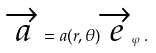<formula> <loc_0><loc_0><loc_500><loc_500>\overrightarrow { a } = a ( r , \theta ) \overrightarrow { e } _ { \varphi } \, . \,</formula> 